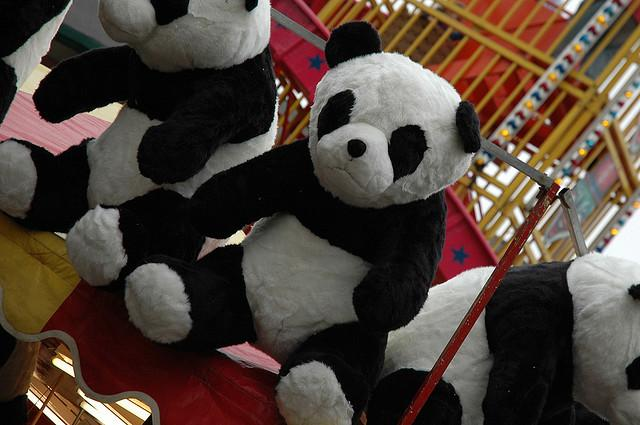This animal is a symbol of what nation? china 